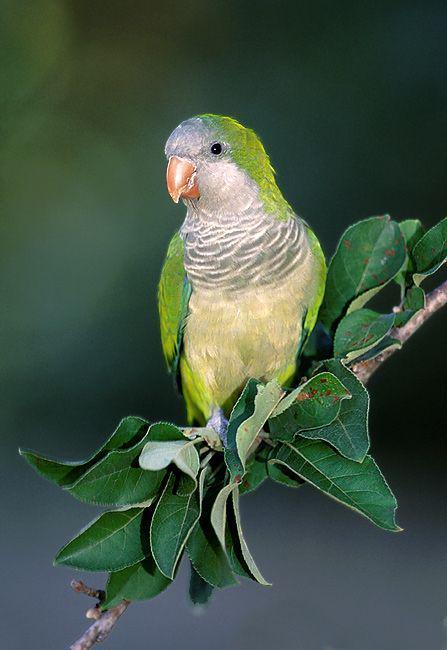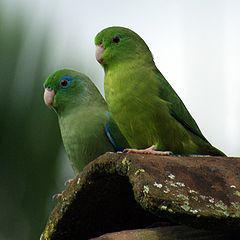The first image is the image on the left, the second image is the image on the right. Considering the images on both sides, is "There are exactly two birds in one of the images." valid? Answer yes or no. Yes. The first image is the image on the left, the second image is the image on the right. For the images shown, is this caption "All green parrots have orange chest areas." true? Answer yes or no. No. 